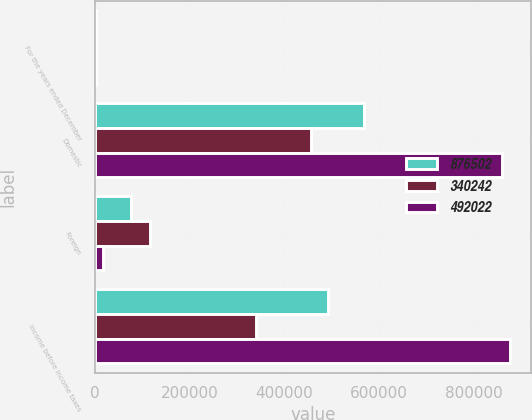Convert chart. <chart><loc_0><loc_0><loc_500><loc_500><stacked_bar_chart><ecel><fcel>For the years ended December<fcel>Domestic<fcel>Foreign<fcel>Income before income taxes<nl><fcel>876502<fcel>2008<fcel>568282<fcel>76260<fcel>492022<nl><fcel>340242<fcel>2007<fcel>456856<fcel>116614<fcel>340242<nl><fcel>492022<fcel>2006<fcel>860655<fcel>15847<fcel>876502<nl></chart> 